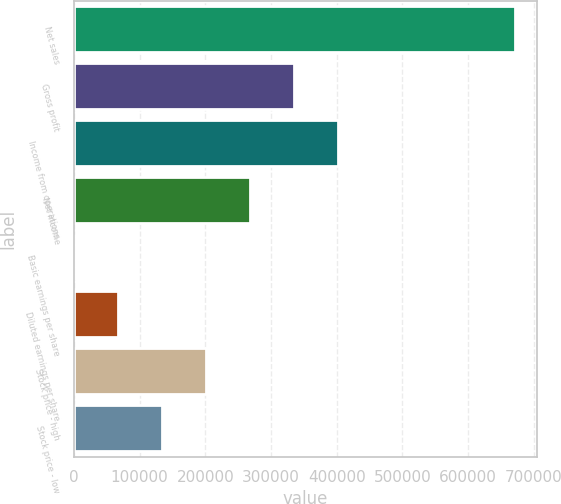Convert chart to OTSL. <chart><loc_0><loc_0><loc_500><loc_500><bar_chart><fcel>Net sales<fcel>Gross profit<fcel>Income from operations<fcel>Net income<fcel>Basic earnings per share<fcel>Diluted earnings per share<fcel>Stock price - high<fcel>Stock price - low<nl><fcel>671357<fcel>335679<fcel>402814<fcel>268543<fcel>0.18<fcel>67135.9<fcel>201407<fcel>134272<nl></chart> 